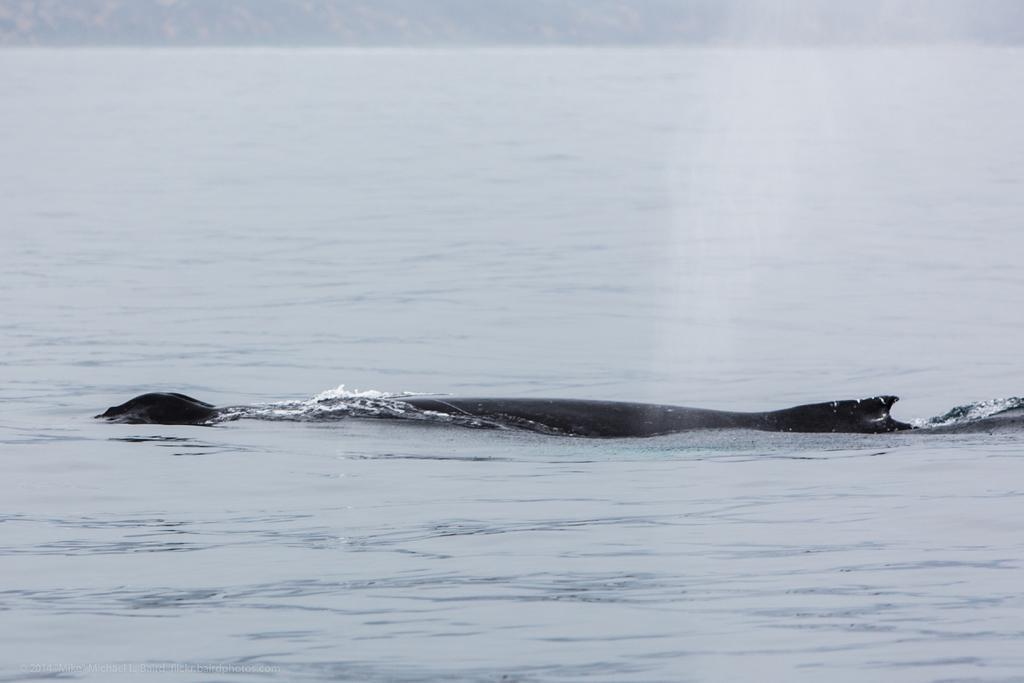Can you describe this image briefly? In this image I can see something in the water. 